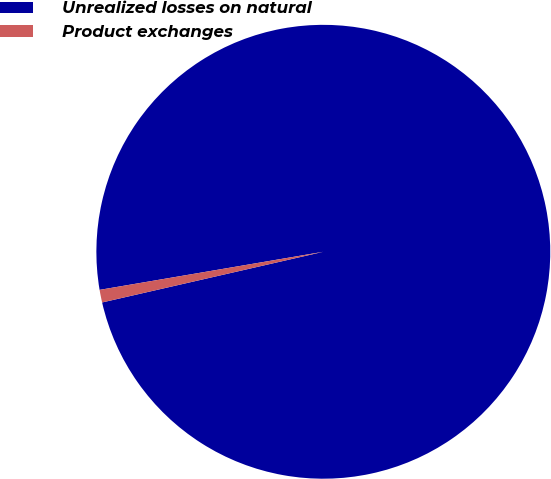<chart> <loc_0><loc_0><loc_500><loc_500><pie_chart><fcel>Unrealized losses on natural<fcel>Product exchanges<nl><fcel>99.1%<fcel>0.9%<nl></chart> 